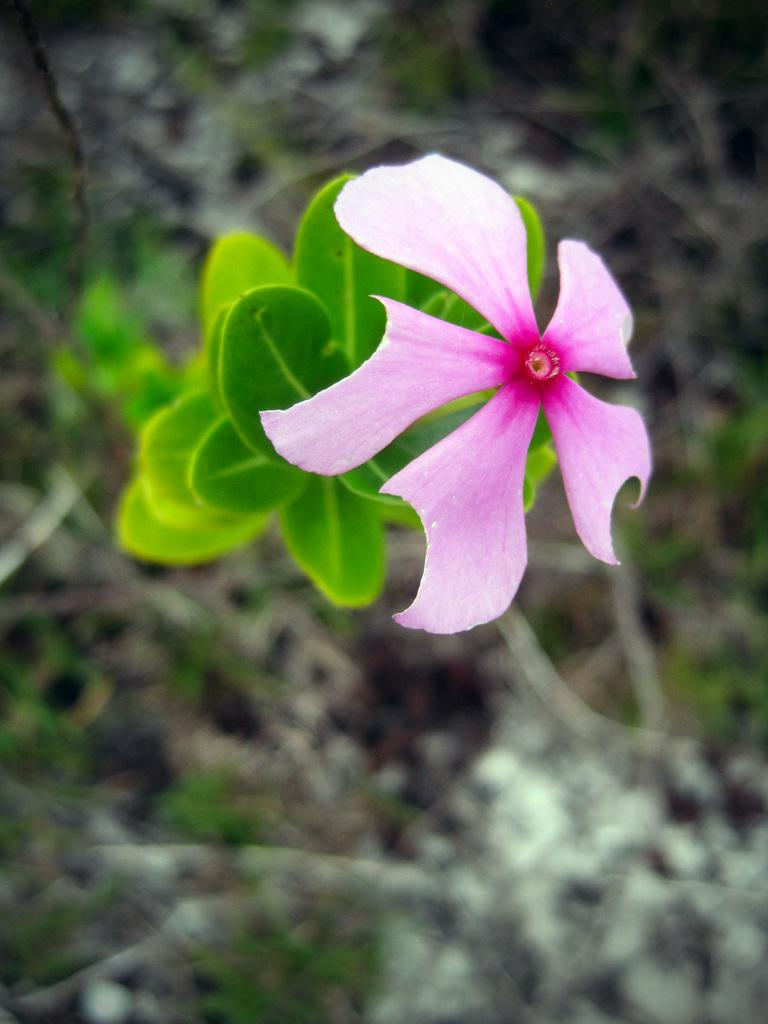What color is the flower in the image? The flower in the image is pink. What type of plant does the flower belong to? The flower is on a plant, but the specific type of plant is not mentioned in the facts. How would you describe the background of the image? The background is blurred. What type of hammer is being used by the bear in the image? There is no bear or hammer present in the image. 